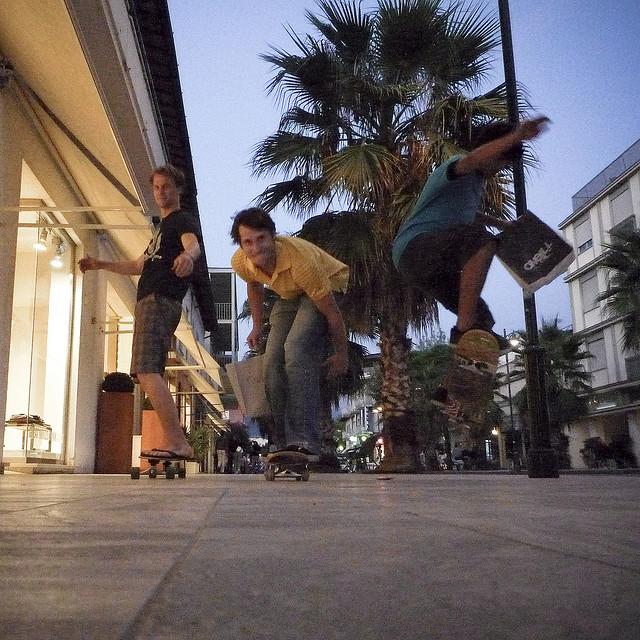What color are the stars?
Keep it brief. White. What kind of tree is in the back?
Short answer required. Palm. What are these people doing?
Quick response, please. Skateboarding. Where are the men playing?
Answer briefly. Street. 